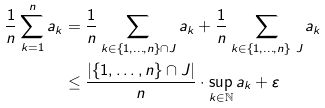<formula> <loc_0><loc_0><loc_500><loc_500>\frac { 1 } { n } \sum _ { k = 1 } ^ { n } a _ { k } & = \frac { 1 } { n } \sum _ { k \in \{ 1 , \dots , n \} \cap J } a _ { k } + \frac { 1 } { n } \sum _ { k \in \{ 1 , \dots , n \} \ J } a _ { k } \\ & \leq \frac { \left | \{ 1 , \dots , n \} \cap J \right | } { n } \cdot \sup _ { k \in \mathbb { N } } a _ { k } + \varepsilon</formula> 